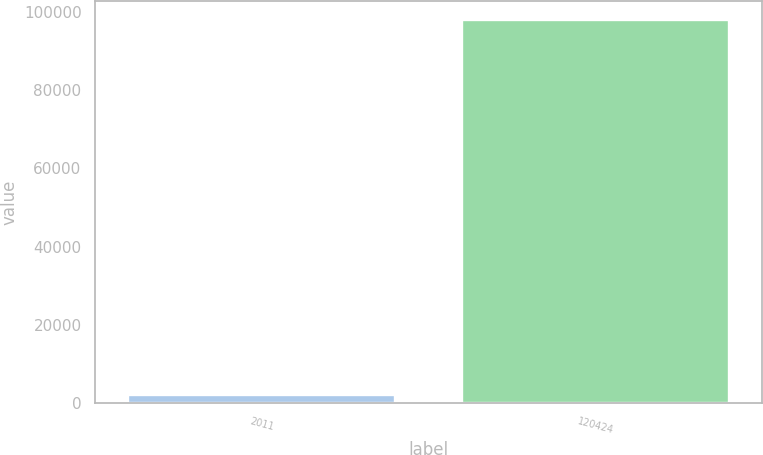Convert chart to OTSL. <chart><loc_0><loc_0><loc_500><loc_500><bar_chart><fcel>2011<fcel>120424<nl><fcel>2010<fcel>97948<nl></chart> 